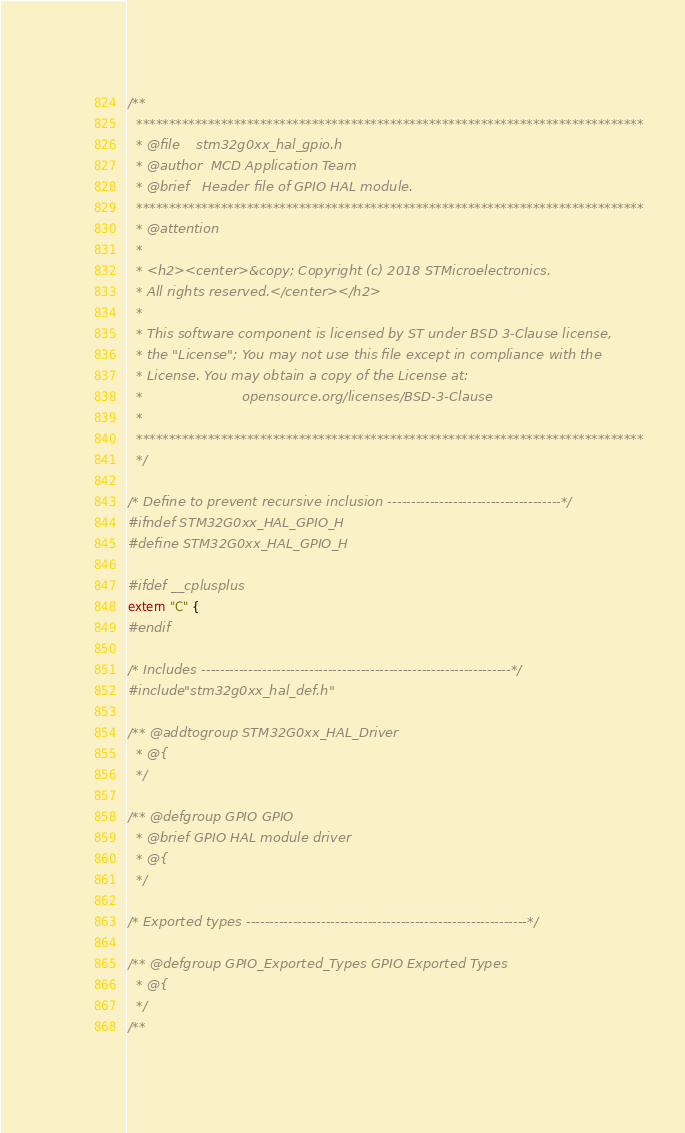Convert code to text. <code><loc_0><loc_0><loc_500><loc_500><_C_>/**
  ******************************************************************************
  * @file    stm32g0xx_hal_gpio.h
  * @author  MCD Application Team
  * @brief   Header file of GPIO HAL module.
  ******************************************************************************
  * @attention
  *
  * <h2><center>&copy; Copyright (c) 2018 STMicroelectronics.
  * All rights reserved.</center></h2>
  *
  * This software component is licensed by ST under BSD 3-Clause license,
  * the "License"; You may not use this file except in compliance with the
  * License. You may obtain a copy of the License at:
  *                        opensource.org/licenses/BSD-3-Clause
  *
  ******************************************************************************
  */

/* Define to prevent recursive inclusion -------------------------------------*/
#ifndef STM32G0xx_HAL_GPIO_H
#define STM32G0xx_HAL_GPIO_H

#ifdef __cplusplus
extern "C" {
#endif

/* Includes ------------------------------------------------------------------*/
#include "stm32g0xx_hal_def.h"

/** @addtogroup STM32G0xx_HAL_Driver
  * @{
  */

/** @defgroup GPIO GPIO
  * @brief GPIO HAL module driver
  * @{
  */

/* Exported types ------------------------------------------------------------*/

/** @defgroup GPIO_Exported_Types GPIO Exported Types
  * @{
  */
/**</code> 